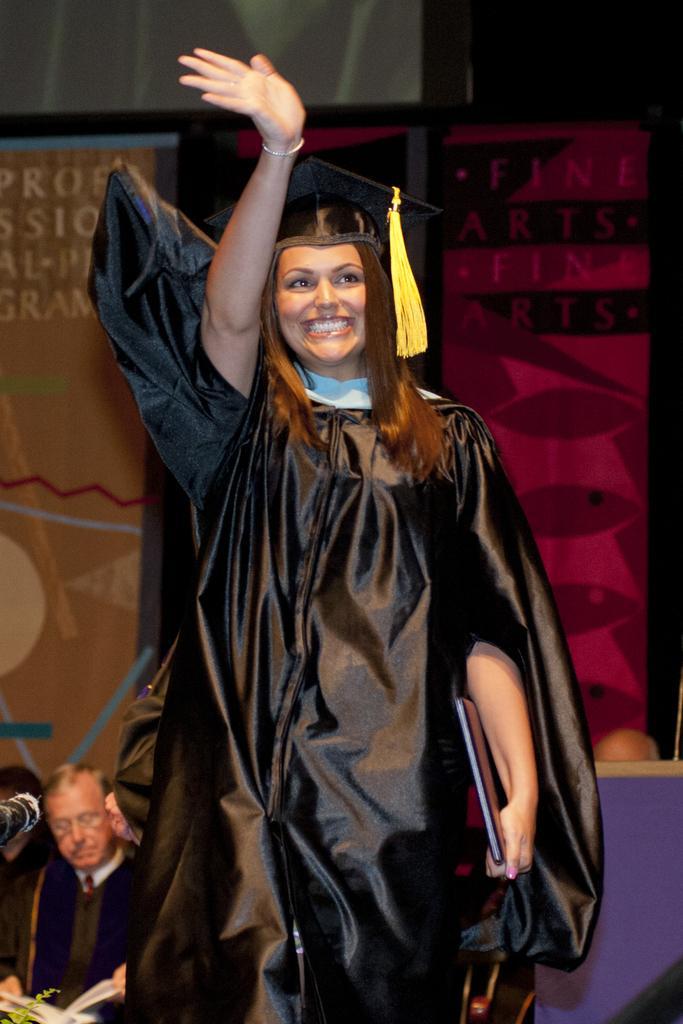In one or two sentences, can you explain what this image depicts? In this image we can see a person and an object. In the background of the image there is a person, name board and other objects. 